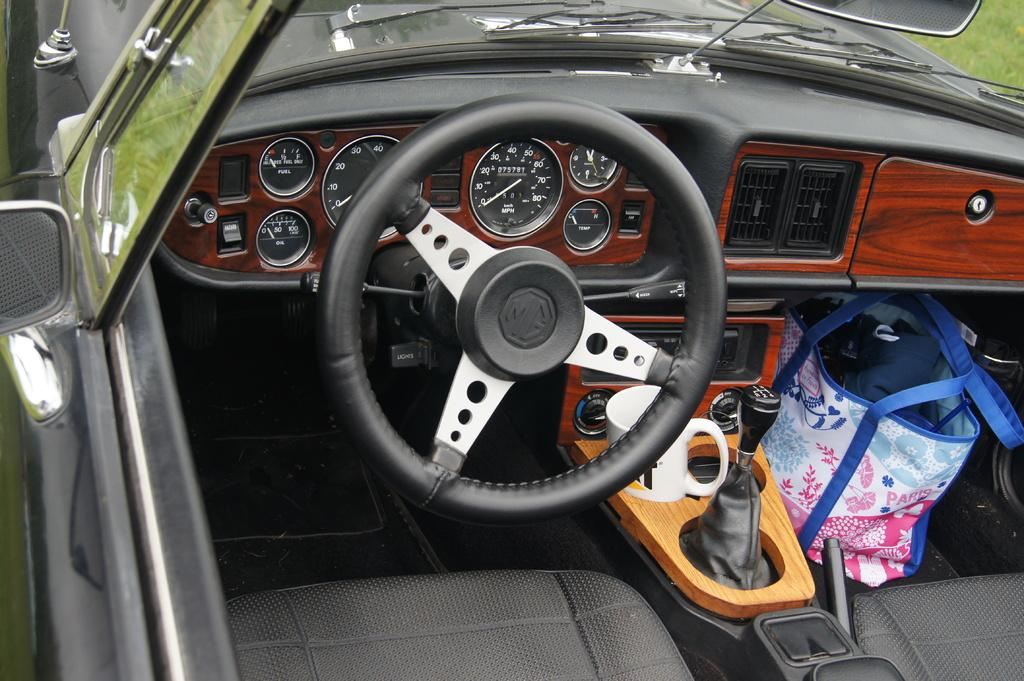What type of location is depicted in the image? The image is an inside view of a car. What is the main control device in the car? There is a steering wheel in the image. What is the driver likely to use for holding a beverage? There is a cup in the image. How does the driver know the current gear selection? The gear is visible in the image. What is used for checking the rear view while driving? There is a mirror in the image. What color is the bag visible in the image? There is a blue color bag in the image. What type of underwear is the driver wearing in the image? There is no information about the driver's clothing in the image, so it cannot be determined. 